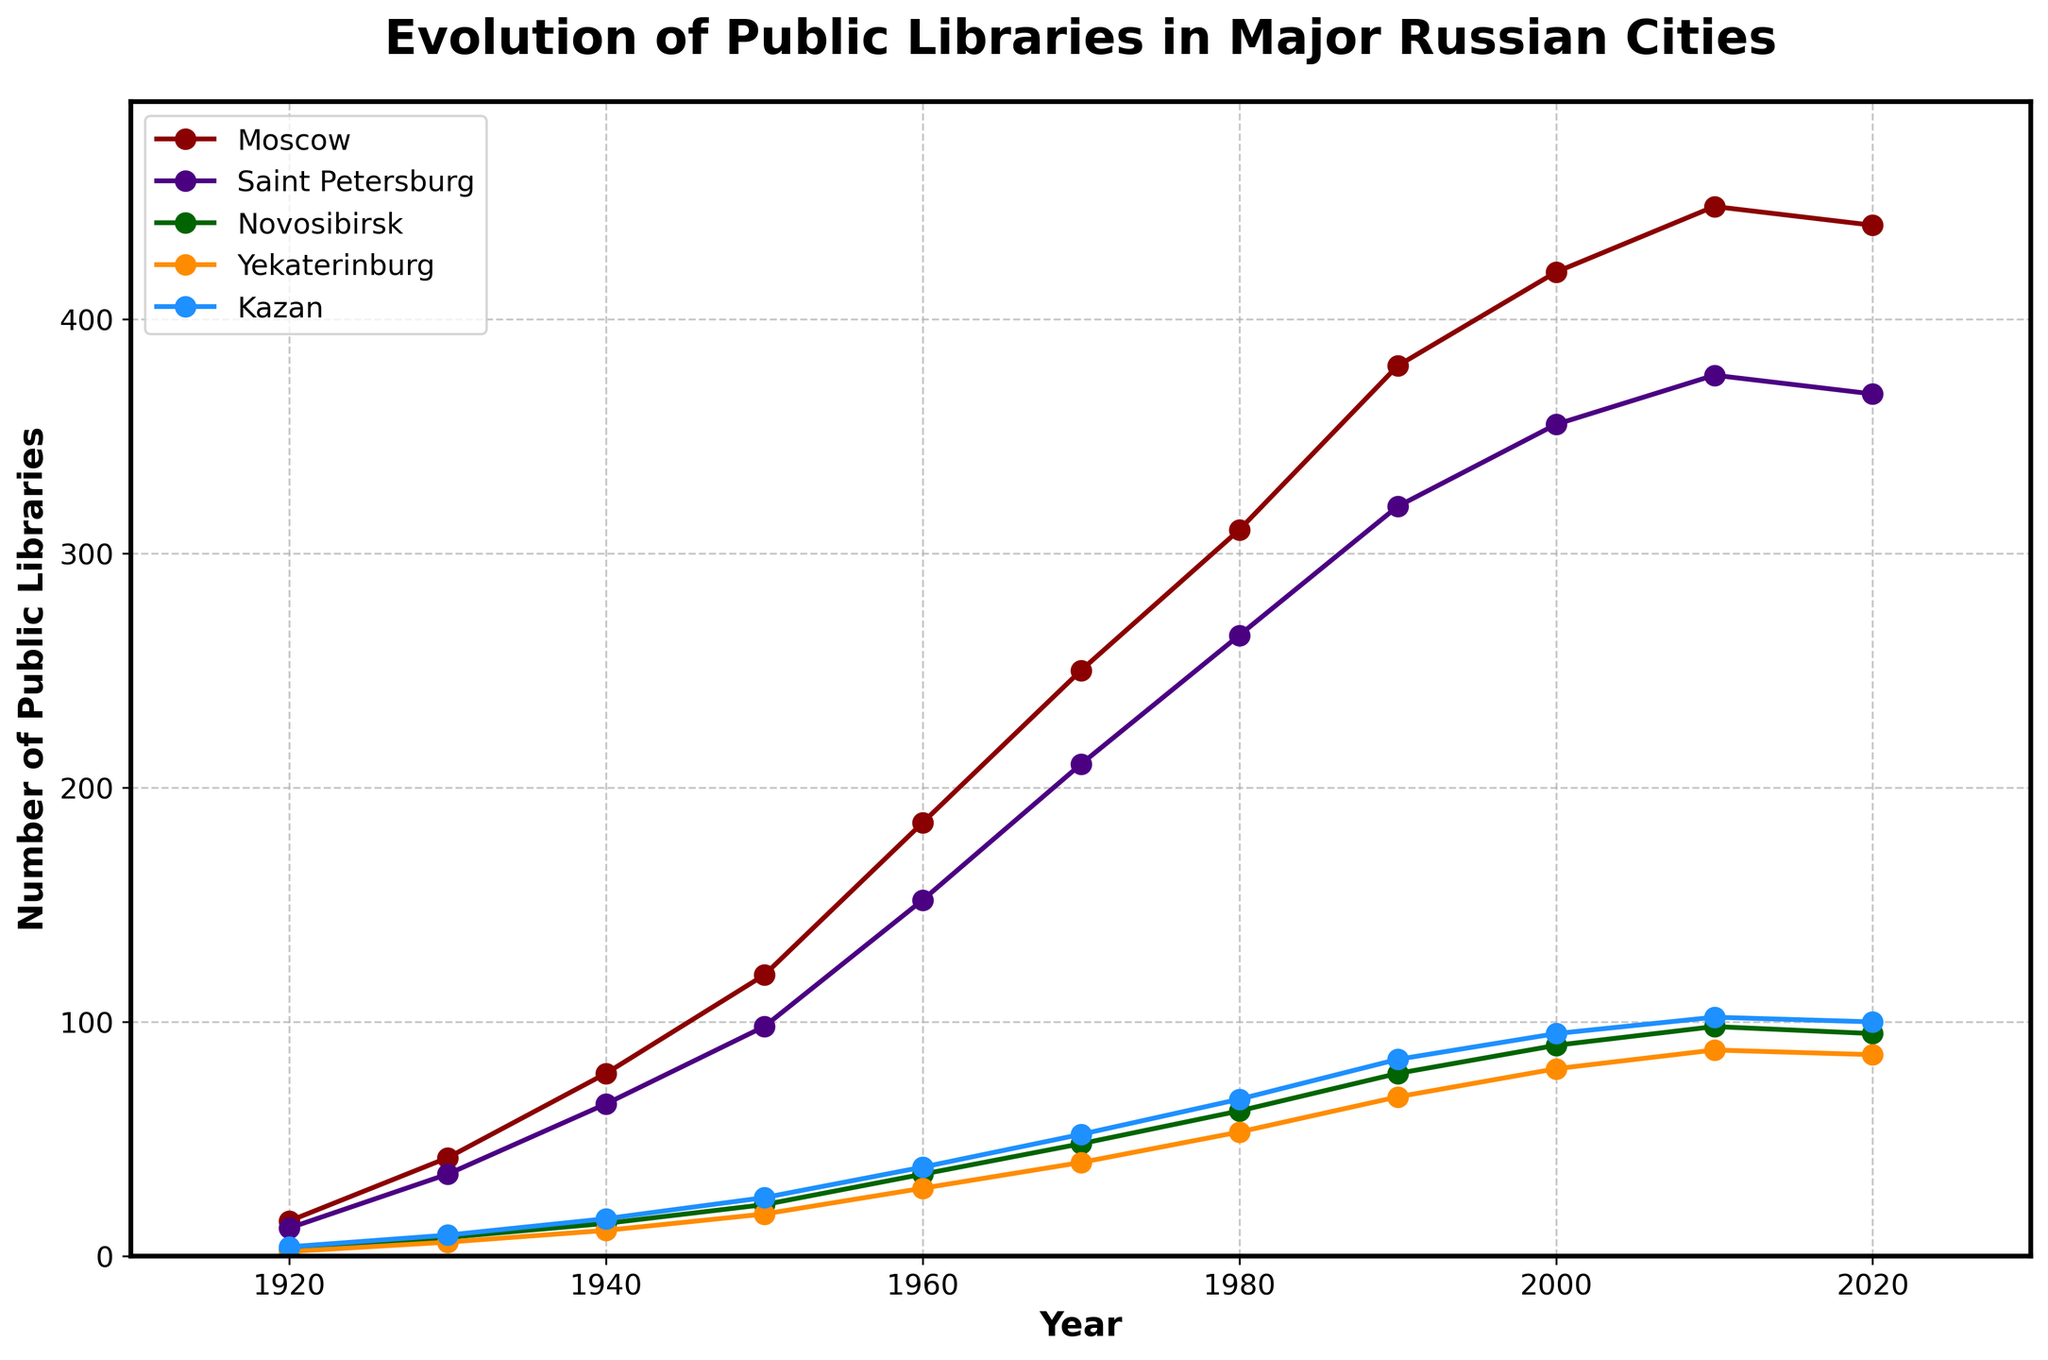How many public libraries were there in Saint Petersburg in 1940, and how does that number compare to the number in 1980? To answer this, look at the corresponding data points on the line representing Saint Petersburg. In 1940, there were 65 libraries. In 1980, there were 265 libraries. The comparison shows an increase of (265 - 65) = 200 libraries.
Answer: 200 Between which two decades did Moscow see the most significant increase in the number of public libraries? Look at the line representing Moscow and identify the steepest slope. The most significant increase appears between 1930 and 1940, where the number jumps from 42 to 78, an increase of 36 libraries.
Answer: 1930-1940 What was the median number of public libraries in Kazan across the entire century? The median is the middle value when all data points are sorted. The data points for Kazan are [4, 9, 16, 25, 38, 52, 67, 84, 95, 102, 100]. When sorted, the median value is the 6th value (since there are 11 data points), which is 52.
Answer: 52 Compare the trend of public libraries in Moscow and Yekaterinburg from 2010 to 2020. Examine the slopes of the lines representing Moscow and Yekaterinburg. From 2010 to 2020, Moscow's line shows a slight decline (448 to 440), whereas Yekaterinburg's line also shows a decline (88 to 86). Both cities show a decreasing trend, but Moscow's decrease is more significant in absolute numbers (8 vs. 2 libraries).
Answer: Both decrease, Moscow has a larger absolute decrease What year did Novosibirsk first surpass 50 public libraries? Look at the line representing Novosibirsk and identify the year when it crosses the 50-libraries mark. From the plot, Novosibirsk surpasses 50 libraries for the first time around 1970.
Answer: 1970 In which decade did Kazan experience the highest growth rate in public libraries? Compare the slopes of Kazan's line for each decade. The steepest slope or highest growth rate is observed between 1940 and 1950, where the number jumps from 16 to 25, an increase of 9 libraries.
Answer: 1940-1950 